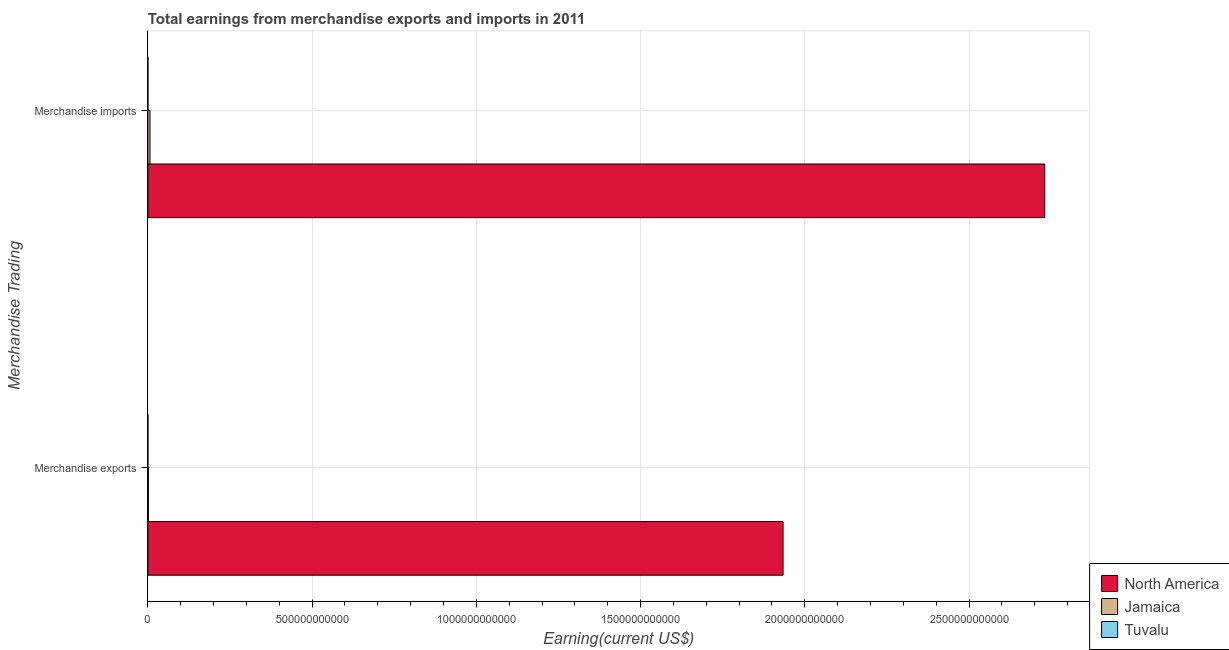Are the number of bars per tick equal to the number of legend labels?
Make the answer very short. Yes. Are the number of bars on each tick of the Y-axis equal?
Your response must be concise. Yes. What is the earnings from merchandise imports in Tuvalu?
Your answer should be compact. 2.50e+07. Across all countries, what is the maximum earnings from merchandise imports?
Your response must be concise. 2.73e+12. Across all countries, what is the minimum earnings from merchandise imports?
Ensure brevity in your answer.  2.50e+07. In which country was the earnings from merchandise imports maximum?
Give a very brief answer. North America. In which country was the earnings from merchandise imports minimum?
Provide a succinct answer. Tuvalu. What is the total earnings from merchandise exports in the graph?
Provide a succinct answer. 1.94e+12. What is the difference between the earnings from merchandise exports in Tuvalu and that in Jamaica?
Your answer should be very brief. -1.62e+09. What is the difference between the earnings from merchandise exports in North America and the earnings from merchandise imports in Tuvalu?
Your answer should be compact. 1.93e+12. What is the average earnings from merchandise exports per country?
Make the answer very short. 6.45e+11. What is the difference between the earnings from merchandise imports and earnings from merchandise exports in North America?
Offer a very short reply. 7.97e+11. In how many countries, is the earnings from merchandise imports greater than 900000000000 US$?
Your answer should be compact. 1. What is the ratio of the earnings from merchandise imports in North America to that in Jamaica?
Ensure brevity in your answer.  424.04. Is the earnings from merchandise exports in Jamaica less than that in Tuvalu?
Make the answer very short. No. What does the 1st bar from the top in Merchandise exports represents?
Provide a short and direct response. Tuvalu. What does the 2nd bar from the bottom in Merchandise imports represents?
Make the answer very short. Jamaica. Are all the bars in the graph horizontal?
Provide a short and direct response. Yes. How many countries are there in the graph?
Ensure brevity in your answer.  3. What is the difference between two consecutive major ticks on the X-axis?
Ensure brevity in your answer.  5.00e+11. Are the values on the major ticks of X-axis written in scientific E-notation?
Keep it short and to the point. No. Does the graph contain grids?
Ensure brevity in your answer.  Yes. Where does the legend appear in the graph?
Your answer should be compact. Bottom right. How many legend labels are there?
Offer a terse response. 3. How are the legend labels stacked?
Your answer should be very brief. Vertical. What is the title of the graph?
Give a very brief answer. Total earnings from merchandise exports and imports in 2011. What is the label or title of the X-axis?
Offer a very short reply. Earning(current US$). What is the label or title of the Y-axis?
Provide a short and direct response. Merchandise Trading. What is the Earning(current US$) in North America in Merchandise exports?
Provide a succinct answer. 1.93e+12. What is the Earning(current US$) of Jamaica in Merchandise exports?
Make the answer very short. 1.62e+09. What is the Earning(current US$) in Tuvalu in Merchandise exports?
Offer a terse response. 3.00e+05. What is the Earning(current US$) of North America in Merchandise imports?
Keep it short and to the point. 2.73e+12. What is the Earning(current US$) in Jamaica in Merchandise imports?
Ensure brevity in your answer.  6.44e+09. What is the Earning(current US$) of Tuvalu in Merchandise imports?
Ensure brevity in your answer.  2.50e+07. Across all Merchandise Trading, what is the maximum Earning(current US$) in North America?
Make the answer very short. 2.73e+12. Across all Merchandise Trading, what is the maximum Earning(current US$) of Jamaica?
Your response must be concise. 6.44e+09. Across all Merchandise Trading, what is the maximum Earning(current US$) of Tuvalu?
Your answer should be very brief. 2.50e+07. Across all Merchandise Trading, what is the minimum Earning(current US$) in North America?
Keep it short and to the point. 1.93e+12. Across all Merchandise Trading, what is the minimum Earning(current US$) in Jamaica?
Your answer should be very brief. 1.62e+09. What is the total Earning(current US$) in North America in the graph?
Your answer should be very brief. 4.66e+12. What is the total Earning(current US$) in Jamaica in the graph?
Your answer should be very brief. 8.06e+09. What is the total Earning(current US$) of Tuvalu in the graph?
Provide a succinct answer. 2.53e+07. What is the difference between the Earning(current US$) in North America in Merchandise exports and that in Merchandise imports?
Offer a terse response. -7.97e+11. What is the difference between the Earning(current US$) of Jamaica in Merchandise exports and that in Merchandise imports?
Offer a very short reply. -4.82e+09. What is the difference between the Earning(current US$) in Tuvalu in Merchandise exports and that in Merchandise imports?
Provide a short and direct response. -2.47e+07. What is the difference between the Earning(current US$) in North America in Merchandise exports and the Earning(current US$) in Jamaica in Merchandise imports?
Provide a short and direct response. 1.93e+12. What is the difference between the Earning(current US$) of North America in Merchandise exports and the Earning(current US$) of Tuvalu in Merchandise imports?
Offer a very short reply. 1.93e+12. What is the difference between the Earning(current US$) in Jamaica in Merchandise exports and the Earning(current US$) in Tuvalu in Merchandise imports?
Offer a very short reply. 1.60e+09. What is the average Earning(current US$) of North America per Merchandise Trading?
Offer a very short reply. 2.33e+12. What is the average Earning(current US$) of Jamaica per Merchandise Trading?
Offer a terse response. 4.03e+09. What is the average Earning(current US$) of Tuvalu per Merchandise Trading?
Your answer should be very brief. 1.26e+07. What is the difference between the Earning(current US$) in North America and Earning(current US$) in Jamaica in Merchandise exports?
Keep it short and to the point. 1.93e+12. What is the difference between the Earning(current US$) in North America and Earning(current US$) in Tuvalu in Merchandise exports?
Ensure brevity in your answer.  1.93e+12. What is the difference between the Earning(current US$) of Jamaica and Earning(current US$) of Tuvalu in Merchandise exports?
Give a very brief answer. 1.62e+09. What is the difference between the Earning(current US$) of North America and Earning(current US$) of Jamaica in Merchandise imports?
Your answer should be compact. 2.72e+12. What is the difference between the Earning(current US$) in North America and Earning(current US$) in Tuvalu in Merchandise imports?
Keep it short and to the point. 2.73e+12. What is the difference between the Earning(current US$) in Jamaica and Earning(current US$) in Tuvalu in Merchandise imports?
Your response must be concise. 6.41e+09. What is the ratio of the Earning(current US$) of North America in Merchandise exports to that in Merchandise imports?
Make the answer very short. 0.71. What is the ratio of the Earning(current US$) in Jamaica in Merchandise exports to that in Merchandise imports?
Make the answer very short. 0.25. What is the ratio of the Earning(current US$) of Tuvalu in Merchandise exports to that in Merchandise imports?
Offer a very short reply. 0.01. What is the difference between the highest and the second highest Earning(current US$) in North America?
Your response must be concise. 7.97e+11. What is the difference between the highest and the second highest Earning(current US$) of Jamaica?
Your answer should be very brief. 4.82e+09. What is the difference between the highest and the second highest Earning(current US$) of Tuvalu?
Give a very brief answer. 2.47e+07. What is the difference between the highest and the lowest Earning(current US$) in North America?
Make the answer very short. 7.97e+11. What is the difference between the highest and the lowest Earning(current US$) of Jamaica?
Offer a very short reply. 4.82e+09. What is the difference between the highest and the lowest Earning(current US$) in Tuvalu?
Ensure brevity in your answer.  2.47e+07. 